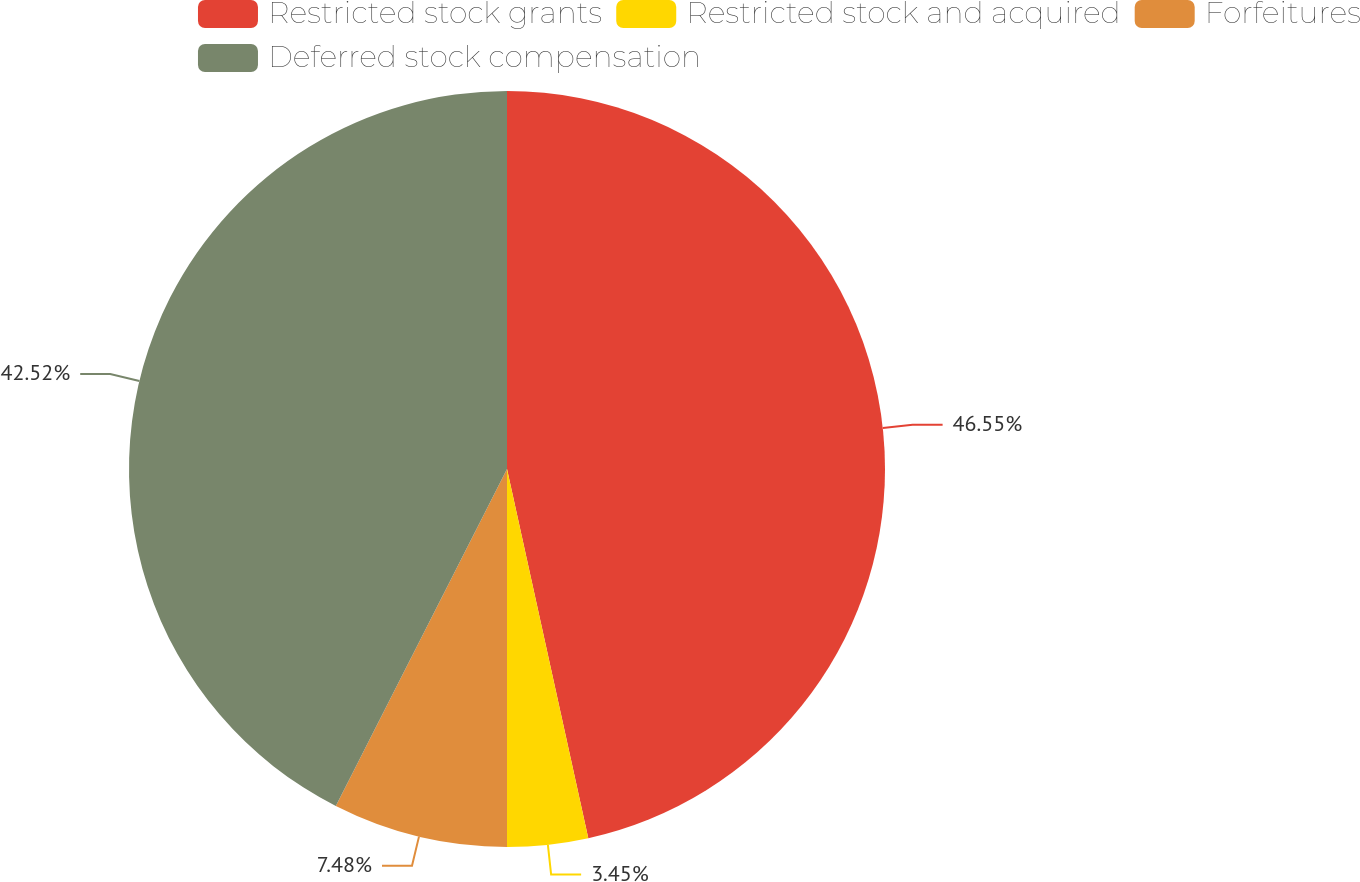<chart> <loc_0><loc_0><loc_500><loc_500><pie_chart><fcel>Restricted stock grants<fcel>Restricted stock and acquired<fcel>Forfeitures<fcel>Deferred stock compensation<nl><fcel>46.55%<fcel>3.45%<fcel>7.48%<fcel>42.52%<nl></chart> 